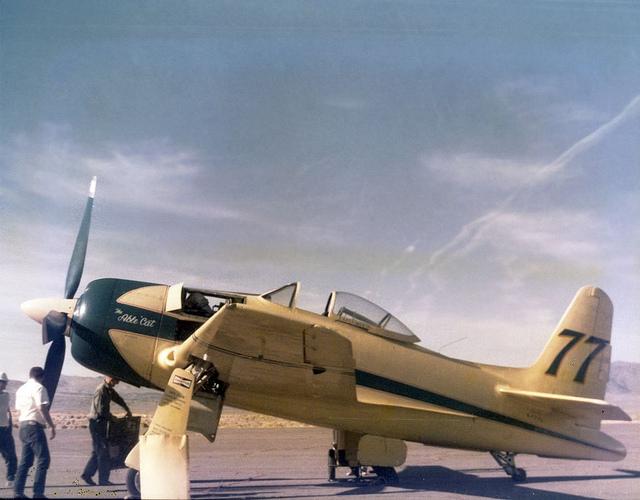What is the number on the back of the airplane?
Short answer required. 77. What kind of aircraft is this?
Give a very brief answer. Plane. How many propellers does the airplane have?
Answer briefly. 1. 